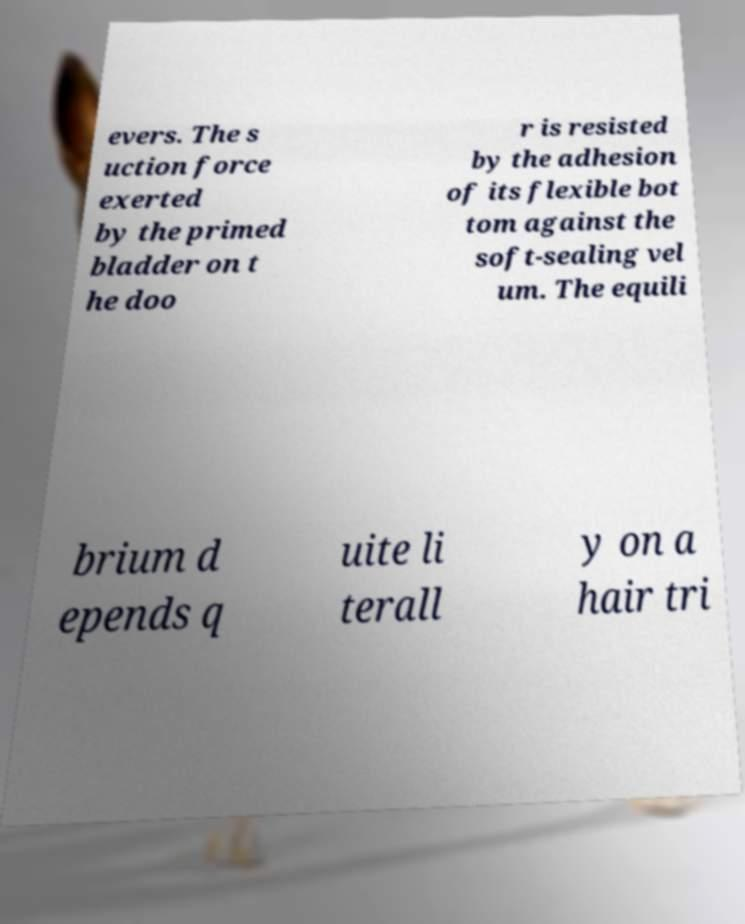I need the written content from this picture converted into text. Can you do that? evers. The s uction force exerted by the primed bladder on t he doo r is resisted by the adhesion of its flexible bot tom against the soft-sealing vel um. The equili brium d epends q uite li terall y on a hair tri 